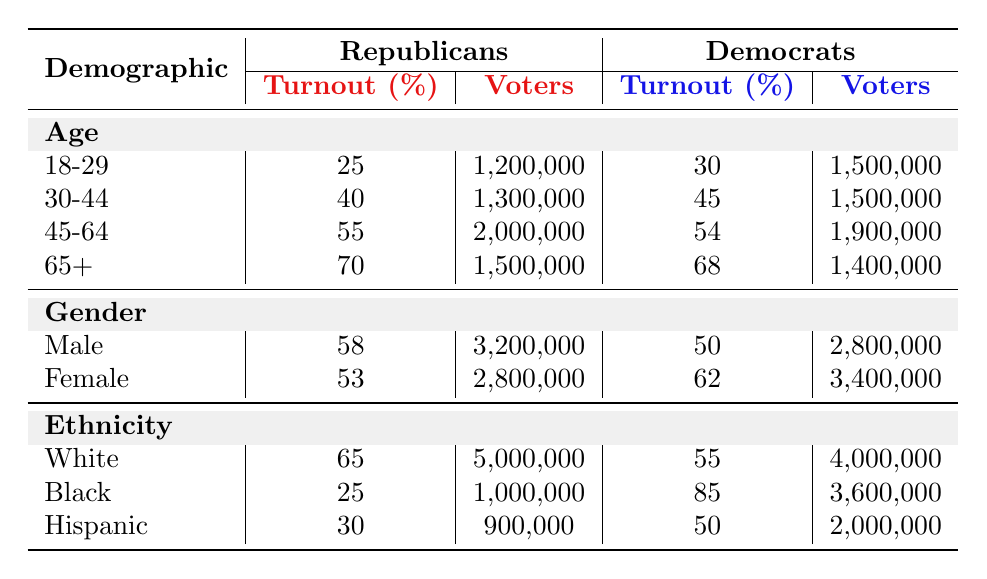What is the voter turnout percentage for Republicans aged 18-29? The table shows that the voter turnout percentage for Republicans in the 18-29 age group is listed under the "Age" demographic. In that category, it reads 25%.
Answer: 25% What is the total number of Hispanic Democratic voters? You can find the number of Hispanic Democratic voters under the "Ethnicity" demographic in the Hispanic category, which states 2,000,000 voters.
Answer: 2,000,000 Who had higher voter turnout, Republicans or Democrats, in the 45-64 age group? Comparing the percentages in the "Age" demographic for the 45-64 age group, Republicans had a turnout of 55%, while Democrats had 54%. Thus, Republicans had a higher turnout by 1%.
Answer: Republicans What is the difference in voter turnout percentage between male Republicans and female Democrats? First, find the turnout percentage for male Republicans, which is 58%, and for female Democrats, which is 62%. Calculating the difference: 62% - 58% = 4%.
Answer: 4% Are there more Republican voters or Democratic voters among the Black demographic? According to the table, Republicans had 1,000,000 voters, and Democrats had 3,600,000. As 3,600,000 is greater than 1,000,000, Democrats had more voters.
Answer: Yes What age group has the highest Republican voter turnout, and what is that percentage? Looking through the voter turnout percentages for the age groups, you see that the 65+ age group has the highest percentage at 70%.
Answer: 65+ How many total voters participated from the 30-44 age group for both parties? For the 30-44 age group, Republicans had 1,300,000 voters and Democrats had 1,500,000 voters. Adding these together gives: 1,300,000 + 1,500,000 = 2,800,000 voters.
Answer: 2,800,000 Which demographic had the lowest voter turnout percentage among Republicans? Checking the percentages for Republicans across all demographics, the lowest turnout is found in the Black demographic at 25%.
Answer: Black demographic What is the total number of male and female Democratic voters combined? From the table, Democratic male voters are 2,800,000, and female voters are 3,400,000. Adding these gives: 2,800,000 + 3,400,000 = 6,200,000 voters.
Answer: 6,200,000 In which demographic do Democrats have the highest voter turnout percentage? By examining the table, Democrats have their highest turnout percentage in the Black demographic with 85%.
Answer: Black demographic 